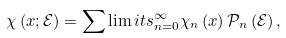<formula> <loc_0><loc_0><loc_500><loc_500>\chi \left ( x ; \mathcal { E } \right ) = \sum \lim i t s _ { n = 0 } ^ { \infty } \chi _ { n } \left ( x \right ) \mathcal { P } _ { n } \left ( \mathcal { E } \right ) ,</formula> 